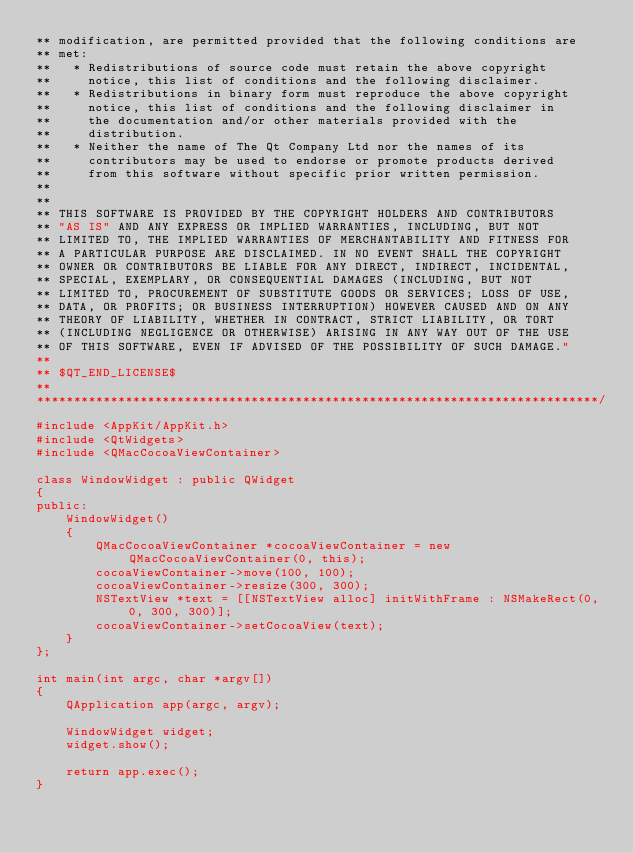<code> <loc_0><loc_0><loc_500><loc_500><_ObjectiveC_>** modification, are permitted provided that the following conditions are
** met:
**   * Redistributions of source code must retain the above copyright
**     notice, this list of conditions and the following disclaimer.
**   * Redistributions in binary form must reproduce the above copyright
**     notice, this list of conditions and the following disclaimer in
**     the documentation and/or other materials provided with the
**     distribution.
**   * Neither the name of The Qt Company Ltd nor the names of its
**     contributors may be used to endorse or promote products derived
**     from this software without specific prior written permission.
**
**
** THIS SOFTWARE IS PROVIDED BY THE COPYRIGHT HOLDERS AND CONTRIBUTORS
** "AS IS" AND ANY EXPRESS OR IMPLIED WARRANTIES, INCLUDING, BUT NOT
** LIMITED TO, THE IMPLIED WARRANTIES OF MERCHANTABILITY AND FITNESS FOR
** A PARTICULAR PURPOSE ARE DISCLAIMED. IN NO EVENT SHALL THE COPYRIGHT
** OWNER OR CONTRIBUTORS BE LIABLE FOR ANY DIRECT, INDIRECT, INCIDENTAL,
** SPECIAL, EXEMPLARY, OR CONSEQUENTIAL DAMAGES (INCLUDING, BUT NOT
** LIMITED TO, PROCUREMENT OF SUBSTITUTE GOODS OR SERVICES; LOSS OF USE,
** DATA, OR PROFITS; OR BUSINESS INTERRUPTION) HOWEVER CAUSED AND ON ANY
** THEORY OF LIABILITY, WHETHER IN CONTRACT, STRICT LIABILITY, OR TORT
** (INCLUDING NEGLIGENCE OR OTHERWISE) ARISING IN ANY WAY OUT OF THE USE
** OF THIS SOFTWARE, EVEN IF ADVISED OF THE POSSIBILITY OF SUCH DAMAGE."
**
** $QT_END_LICENSE$
**
****************************************************************************/

#include <AppKit/AppKit.h>
#include <QtWidgets>
#include <QMacCocoaViewContainer>

class WindowWidget : public QWidget
{
public:
    WindowWidget()
    {
        QMacCocoaViewContainer *cocoaViewContainer = new QMacCocoaViewContainer(0, this);
        cocoaViewContainer->move(100, 100);
        cocoaViewContainer->resize(300, 300);
        NSTextView *text = [[NSTextView alloc] initWithFrame : NSMakeRect(0, 0, 300, 300)];
        cocoaViewContainer->setCocoaView(text);
    }
};

int main(int argc, char *argv[])
{
    QApplication app(argc, argv);

    WindowWidget widget;
    widget.show();

    return app.exec();
}
</code> 